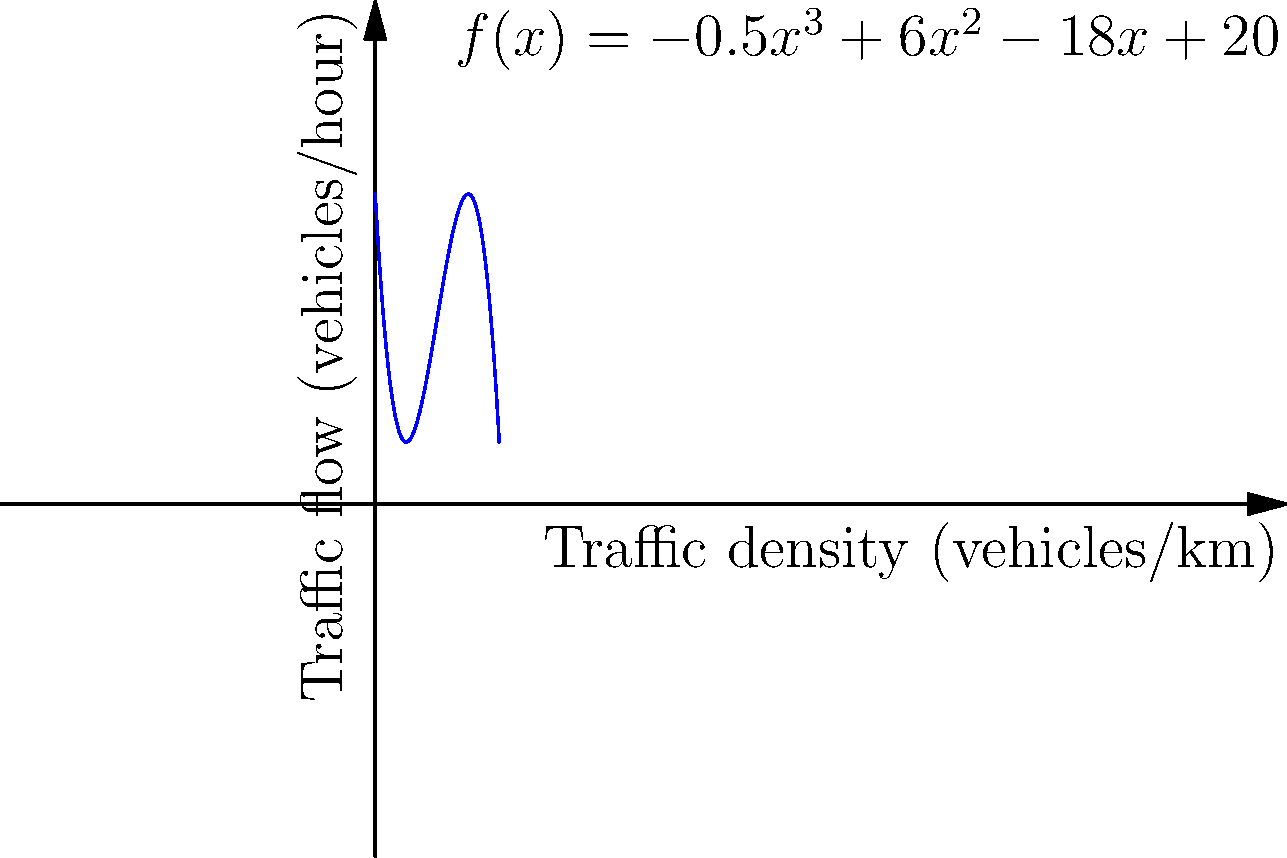Given the polynomial function $f(x) = -0.5x^3 + 6x^2 - 18x + 20$ representing the relationship between traffic density (x, in vehicles/km) and traffic flow (f(x), in vehicles/hour) at a 5G-enabled smart intersection, determine the traffic density that maximizes the traffic flow. Round your answer to the nearest whole number. To find the maximum traffic flow, we need to follow these steps:

1) The maximum point occurs where the derivative of the function is zero. Let's find the derivative:

   $f'(x) = -1.5x^2 + 12x - 18$

2) Set the derivative to zero and solve for x:

   $-1.5x^2 + 12x - 18 = 0$

3) This is a quadratic equation. We can solve it using the quadratic formula:
   $x = \frac{-b \pm \sqrt{b^2 - 4ac}}{2a}$

   Where $a = -1.5$, $b = 12$, and $c = -18$

4) Plugging in these values:

   $x = \frac{-12 \pm \sqrt{12^2 - 4(-1.5)(-18)}}{2(-1.5)}$

5) Simplifying:

   $x = \frac{-12 \pm \sqrt{144 - 108}}{-3} = \frac{-12 \pm \sqrt{36}}{-3} = \frac{-12 \pm 6}{-3}$

6) This gives us two solutions:

   $x = \frac{-12 + 6}{-3} = 2$ or $x = \frac{-12 - 6}{-3} = 6$

7) To determine which of these gives the maximum (rather than minimum) traffic flow, we can check the second derivative:

   $f''(x) = -3x + 12$

8) At $x = 2$: $f''(2) = -3(2) + 12 = 6 > 0$, indicating a local minimum
   At $x = 6$: $f''(6) = -3(6) + 12 = -6 < 0$, indicating a local maximum

Therefore, the traffic flow is maximized when the traffic density is 6 vehicles/km.
Answer: 6 vehicles/km 